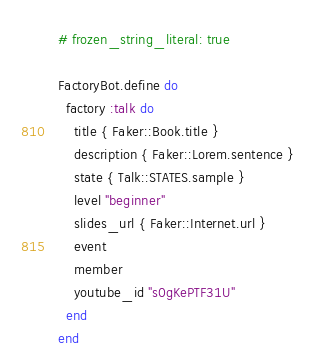<code> <loc_0><loc_0><loc_500><loc_500><_Ruby_># frozen_string_literal: true

FactoryBot.define do
  factory :talk do
    title { Faker::Book.title }
    description { Faker::Lorem.sentence }
    state { Talk::STATES.sample }
    level "beginner"
    slides_url { Faker::Internet.url }
    event
    member
    youtube_id "s0gKePTF31U"
  end
end
</code> 